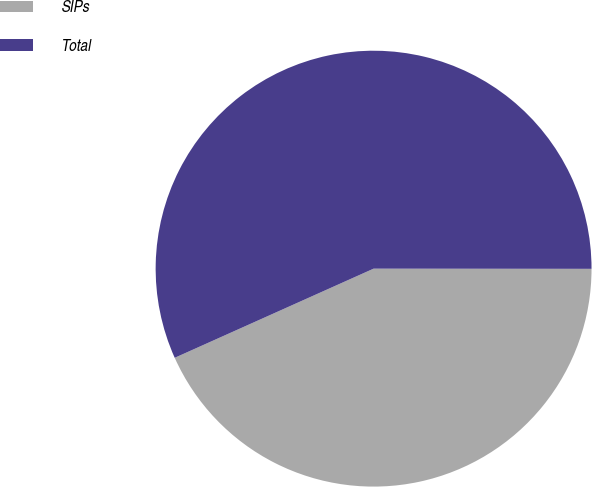<chart> <loc_0><loc_0><loc_500><loc_500><pie_chart><fcel>SIPs<fcel>Total<nl><fcel>43.28%<fcel>56.72%<nl></chart> 